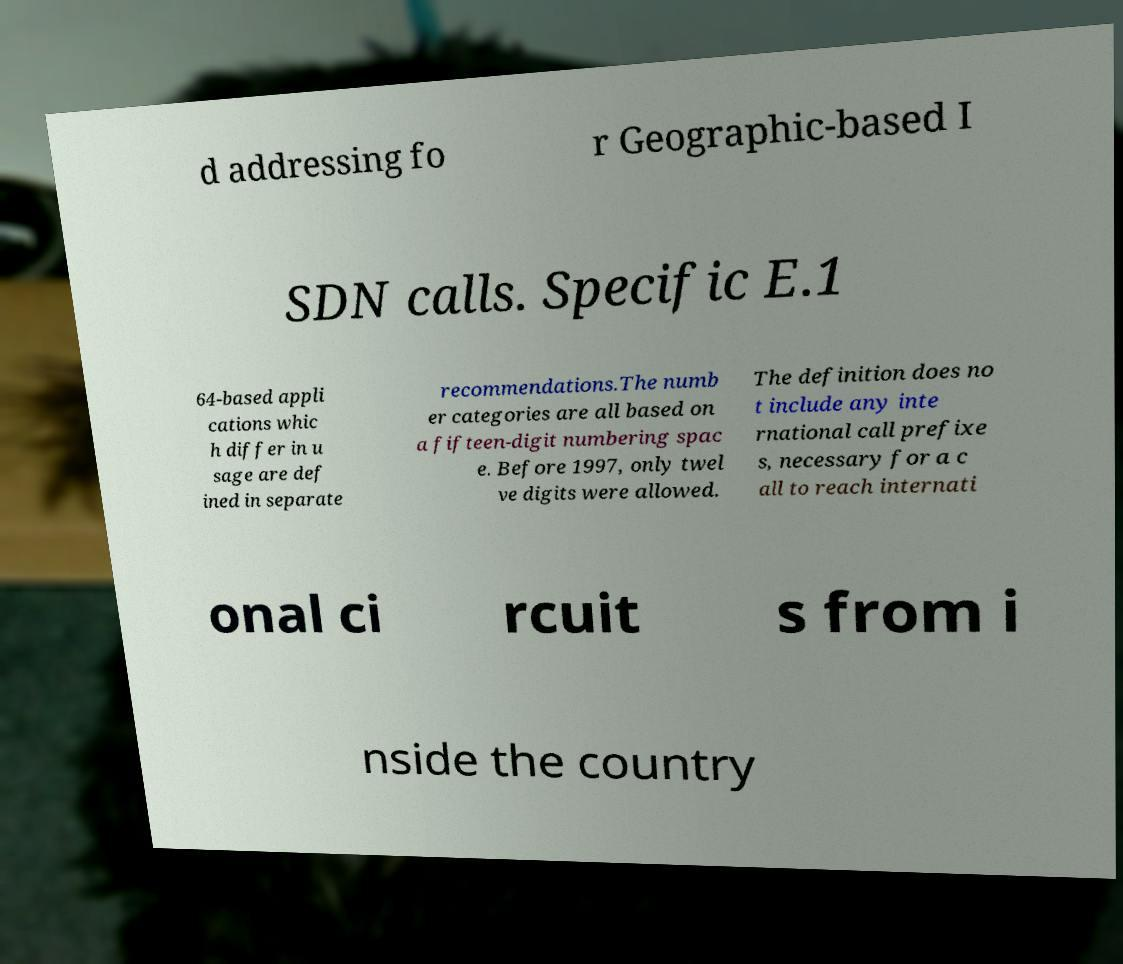Can you accurately transcribe the text from the provided image for me? d addressing fo r Geographic-based I SDN calls. Specific E.1 64-based appli cations whic h differ in u sage are def ined in separate recommendations.The numb er categories are all based on a fifteen-digit numbering spac e. Before 1997, only twel ve digits were allowed. The definition does no t include any inte rnational call prefixe s, necessary for a c all to reach internati onal ci rcuit s from i nside the country 